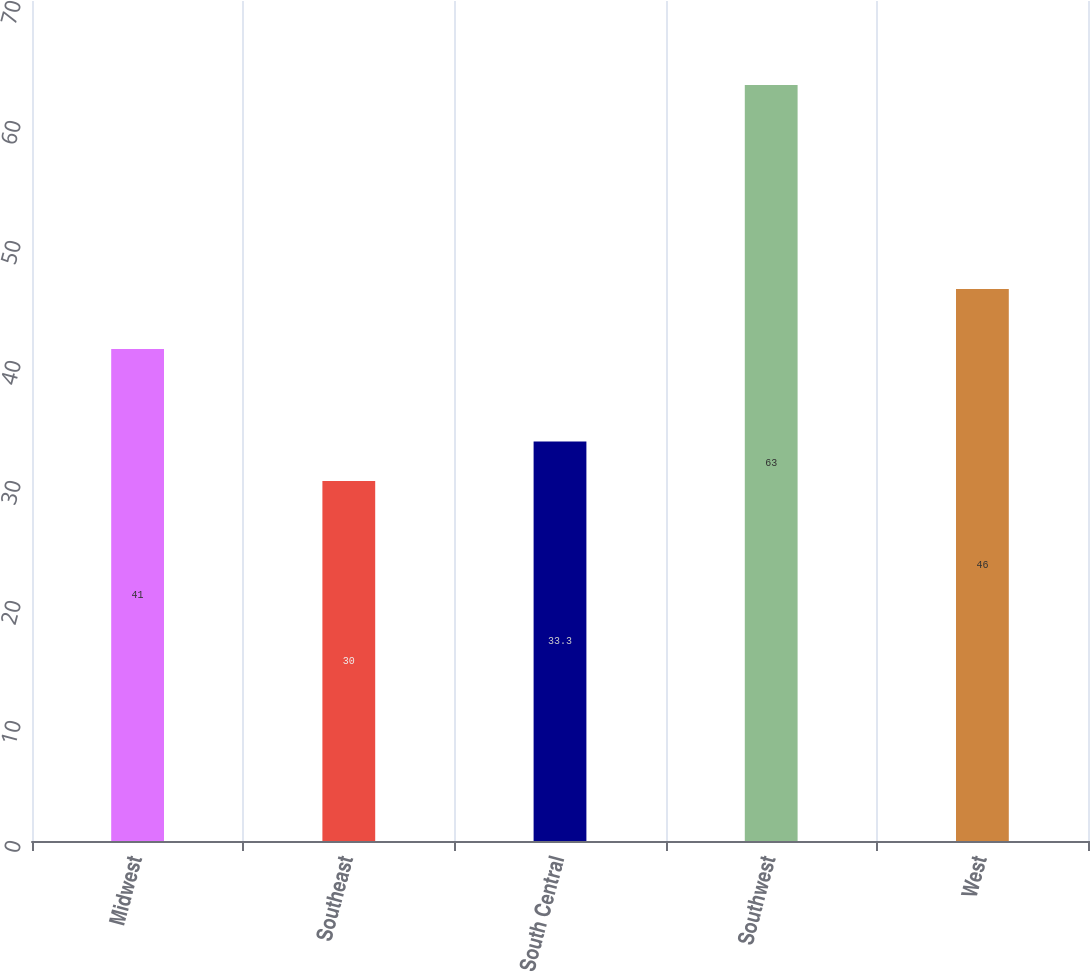Convert chart. <chart><loc_0><loc_0><loc_500><loc_500><bar_chart><fcel>Midwest<fcel>Southeast<fcel>South Central<fcel>Southwest<fcel>West<nl><fcel>41<fcel>30<fcel>33.3<fcel>63<fcel>46<nl></chart> 